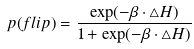Convert formula to latex. <formula><loc_0><loc_0><loc_500><loc_500>p ( f l i p ) = \frac { \exp ( - \beta \cdot \bigtriangleup H ) } { 1 + \exp ( - \beta \cdot \bigtriangleup H ) }</formula> 